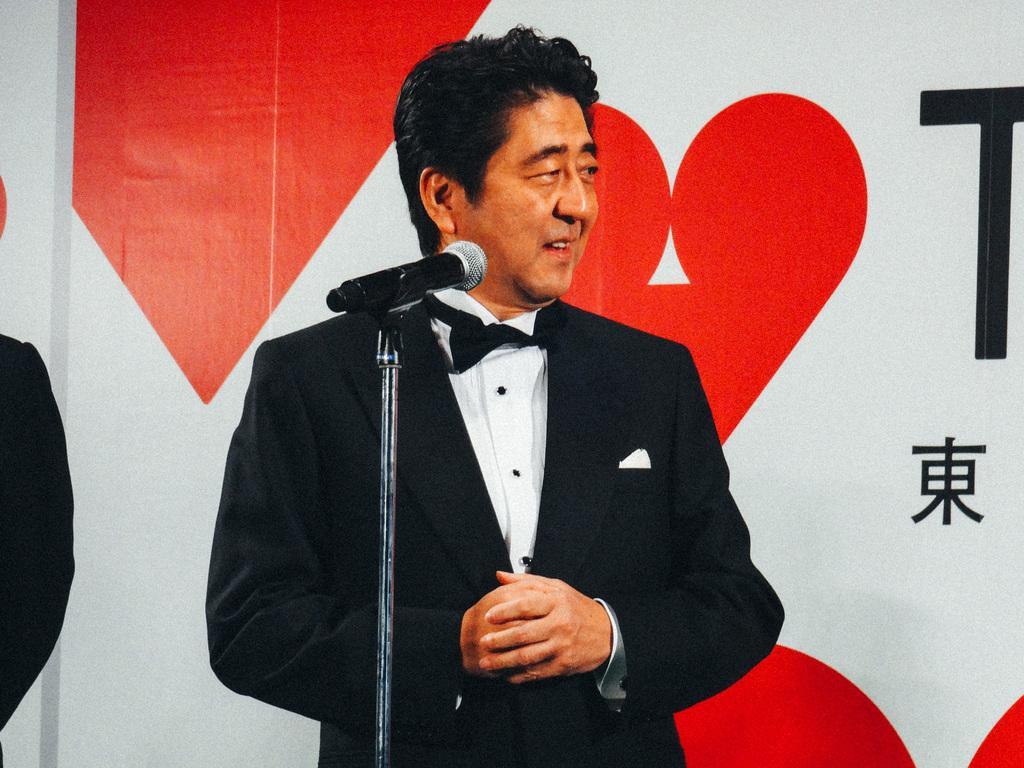Could you give a brief overview of what you see in this image? In this image I can see a person standing in the center of the image in front of the mike facing towards the right and I can see another person's hand on the left side of the image with a white, red and black color background with some text.  